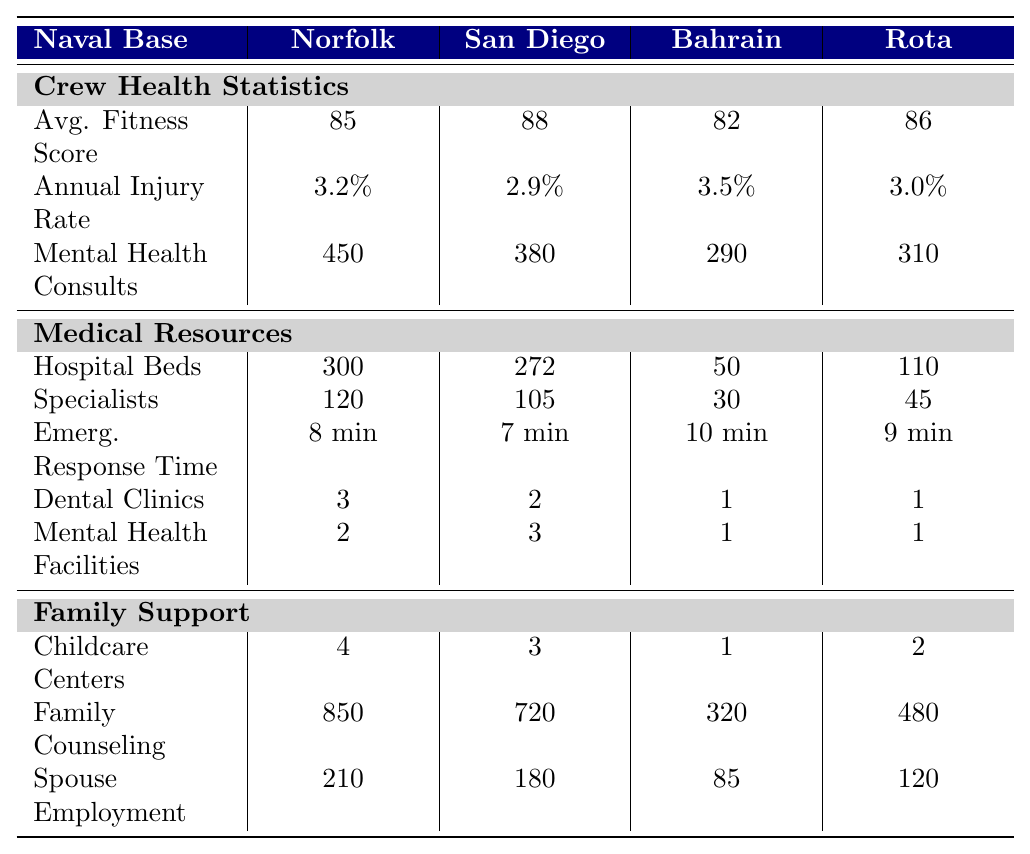What is the average fitness score for crew members in Naval Base San Diego? The fitness score listed for Naval Base San Diego in the table is 88.
Answer: 88 Which naval base has the highest number of family counseling sessions provided? The family counseling sessions for each base are: Norfolk - 850, San Diego - 720, Bahrain - 320, Rota - 480. Norfolk has the highest at 850.
Answer: 850 What is the annual injury rate for crew members at Naval Support Activity Bahrain? The annual injury rate for Naval Support Activity Bahrain is 3.5%, as shown in the table.
Answer: 3.5% How many more mental health consultations were conducted at Naval Station Norfolk compared to Naval Base San Diego? Norfolk had 450 mental health consultations and San Diego had 380. The difference is 450 - 380 = 70.
Answer: 70 True or False: Naval Medical Center at Naval Station Norfolk has more beds than the naval medical resources in Naval Base San Diego. Norfolk has 300 beds while San Diego has 272 beds. Since 300 > 272, the statement is true.
Answer: True What is the total number of childcare centers across all four naval bases? The total childcare centers are: Norfolk - 4, San Diego - 3, Bahrain - 1, Rota - 2. The total is 4 + 3 + 1 + 2 = 10.
Answer: 10 Which base has the shortest emergency response time and what is that time? The emergency response times are: Norfolk - 8 min, San Diego - 7 min, Bahrain - 10 min, Rota - 9 min. San Diego has the shortest at 7 minutes.
Answer: 7 minutes How many more dental clinics does Naval Station Norfolk have compared to Naval Support Activity Bahrain? Norfolk has 3 dental clinics while Bahrain has 1. The difference is 3 - 1 = 2 more dental clinics.
Answer: 2 more dental clinics What is the average number of hospital beds available across all bases? The beds available are: Norfolk - 300, San Diego - 272, Bahrain - 50, Rota - 110. The total is 300 + 272 + 50 + 110 = 732. The average is 732/4 = 183.
Answer: 183 Is the average fitness score for crew members at Naval Base San Diego higher than that at Naval Station Rota? San Diego's average fitness score is 88 and Rota's is 86. Since 88 > 86, the answer is yes.
Answer: Yes 